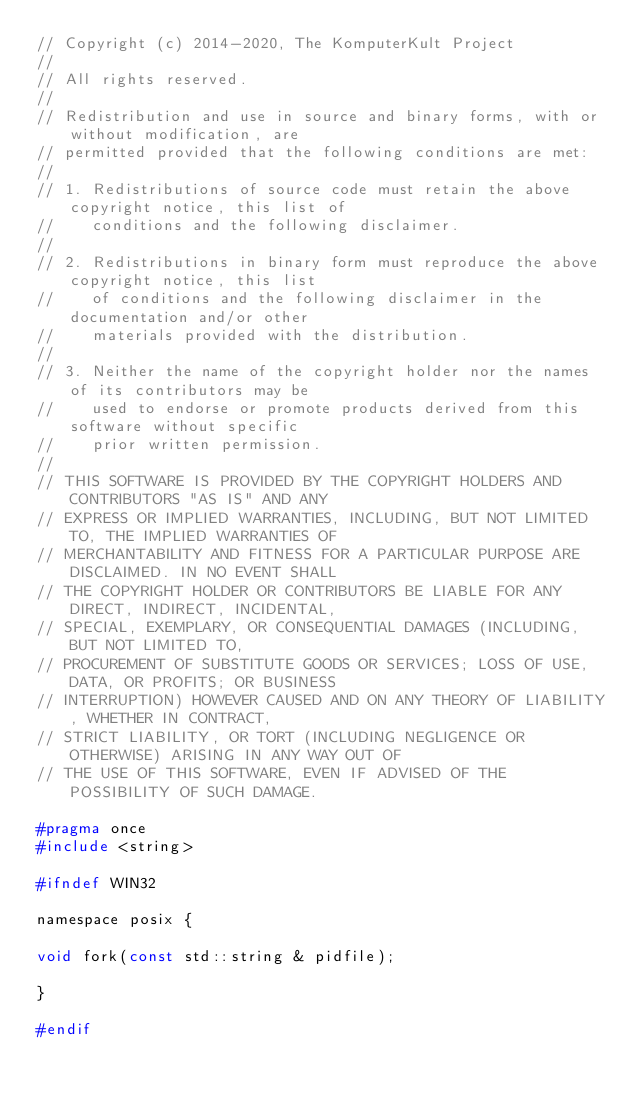<code> <loc_0><loc_0><loc_500><loc_500><_C_>// Copyright (c) 2014-2020, The KomputerKult Project
//
// All rights reserved.
//
// Redistribution and use in source and binary forms, with or without modification, are
// permitted provided that the following conditions are met:
//
// 1. Redistributions of source code must retain the above copyright notice, this list of
//    conditions and the following disclaimer.
//
// 2. Redistributions in binary form must reproduce the above copyright notice, this list
//    of conditions and the following disclaimer in the documentation and/or other
//    materials provided with the distribution.
//
// 3. Neither the name of the copyright holder nor the names of its contributors may be
//    used to endorse or promote products derived from this software without specific
//    prior written permission.
//
// THIS SOFTWARE IS PROVIDED BY THE COPYRIGHT HOLDERS AND CONTRIBUTORS "AS IS" AND ANY
// EXPRESS OR IMPLIED WARRANTIES, INCLUDING, BUT NOT LIMITED TO, THE IMPLIED WARRANTIES OF
// MERCHANTABILITY AND FITNESS FOR A PARTICULAR PURPOSE ARE DISCLAIMED. IN NO EVENT SHALL
// THE COPYRIGHT HOLDER OR CONTRIBUTORS BE LIABLE FOR ANY DIRECT, INDIRECT, INCIDENTAL,
// SPECIAL, EXEMPLARY, OR CONSEQUENTIAL DAMAGES (INCLUDING, BUT NOT LIMITED TO,
// PROCUREMENT OF SUBSTITUTE GOODS OR SERVICES; LOSS OF USE, DATA, OR PROFITS; OR BUSINESS
// INTERRUPTION) HOWEVER CAUSED AND ON ANY THEORY OF LIABILITY, WHETHER IN CONTRACT,
// STRICT LIABILITY, OR TORT (INCLUDING NEGLIGENCE OR OTHERWISE) ARISING IN ANY WAY OUT OF
// THE USE OF THIS SOFTWARE, EVEN IF ADVISED OF THE POSSIBILITY OF SUCH DAMAGE.

#pragma once
#include <string>

#ifndef WIN32

namespace posix {

void fork(const std::string & pidfile);

}

#endif
</code> 